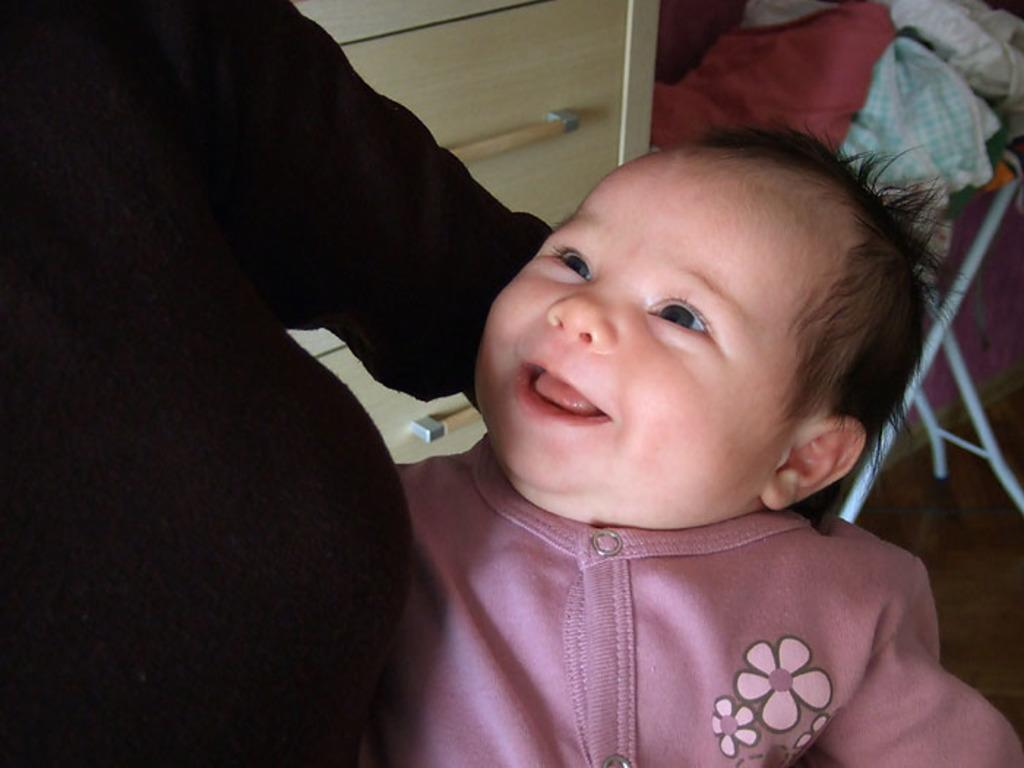What is happening on the left side of the image? There is a person holding a baby on the left side of the image. How does the baby appear to feel in the image? The baby is smiling. What can be seen in the background of the image? There is a cupboard in the background of the image. What is on the floor in the background of the image? There are clothes on an object on the floor in the background. What type of bushes can be seen growing on the person's wing in the image? There is no person with a wing in the image, and therefore no bushes can be seen growing on it. What is the cork used for in the image? There is no cork present in the image. 